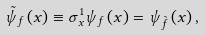<formula> <loc_0><loc_0><loc_500><loc_500>\tilde { \psi } _ { f } \left ( x \right ) \equiv \sigma _ { x } ^ { 1 } \psi _ { f } \left ( x \right ) = \psi _ { \tilde { f } } \left ( x \right ) ,</formula> 